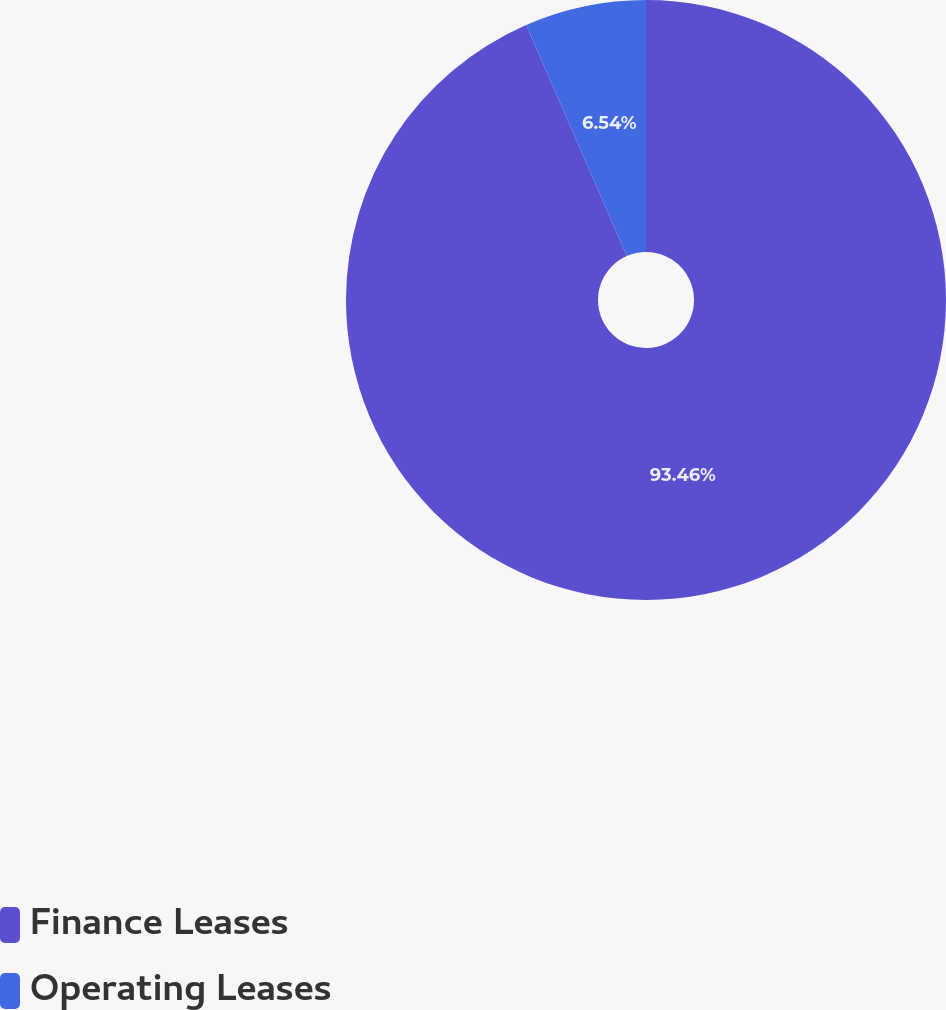Convert chart to OTSL. <chart><loc_0><loc_0><loc_500><loc_500><pie_chart><fcel>Finance Leases<fcel>Operating Leases<nl><fcel>93.46%<fcel>6.54%<nl></chart> 